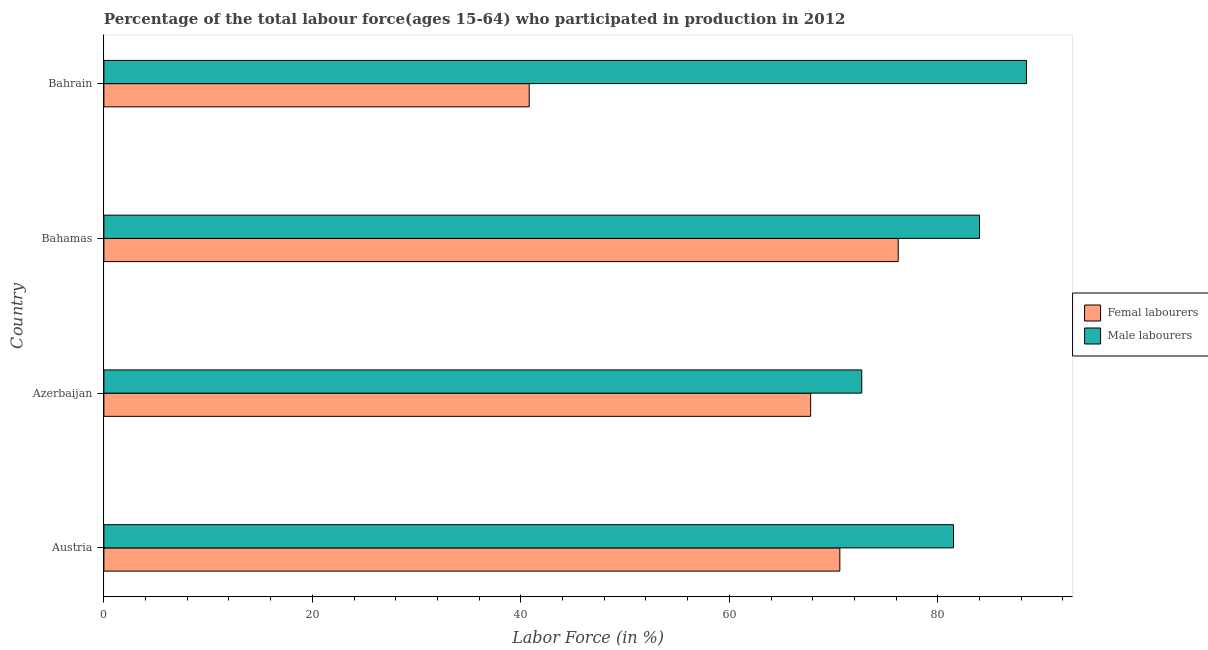How many different coloured bars are there?
Make the answer very short. 2. How many bars are there on the 1st tick from the bottom?
Your answer should be very brief. 2. What is the label of the 2nd group of bars from the top?
Make the answer very short. Bahamas. What is the percentage of male labour force in Bahamas?
Provide a succinct answer. 84. Across all countries, what is the maximum percentage of male labour force?
Provide a succinct answer. 88.5. Across all countries, what is the minimum percentage of female labor force?
Keep it short and to the point. 40.8. In which country was the percentage of male labour force maximum?
Make the answer very short. Bahrain. In which country was the percentage of male labour force minimum?
Provide a short and direct response. Azerbaijan. What is the total percentage of female labor force in the graph?
Offer a terse response. 255.4. What is the difference between the percentage of female labor force in Austria and that in Bahrain?
Offer a very short reply. 29.8. What is the difference between the percentage of male labour force in Azerbaijan and the percentage of female labor force in Bahamas?
Your answer should be very brief. -3.5. What is the average percentage of male labour force per country?
Offer a very short reply. 81.67. What is the ratio of the percentage of female labor force in Austria to that in Bahrain?
Offer a very short reply. 1.73. Is the difference between the percentage of female labor force in Austria and Azerbaijan greater than the difference between the percentage of male labour force in Austria and Azerbaijan?
Offer a very short reply. No. What is the difference between the highest and the lowest percentage of male labour force?
Your answer should be very brief. 15.8. In how many countries, is the percentage of female labor force greater than the average percentage of female labor force taken over all countries?
Your response must be concise. 3. What does the 1st bar from the top in Azerbaijan represents?
Give a very brief answer. Male labourers. What does the 1st bar from the bottom in Bahamas represents?
Your response must be concise. Femal labourers. How many bars are there?
Give a very brief answer. 8. Are the values on the major ticks of X-axis written in scientific E-notation?
Provide a short and direct response. No. Does the graph contain any zero values?
Provide a short and direct response. No. Does the graph contain grids?
Your response must be concise. No. Where does the legend appear in the graph?
Your answer should be very brief. Center right. How many legend labels are there?
Give a very brief answer. 2. What is the title of the graph?
Offer a terse response. Percentage of the total labour force(ages 15-64) who participated in production in 2012. What is the label or title of the X-axis?
Keep it short and to the point. Labor Force (in %). What is the Labor Force (in %) of Femal labourers in Austria?
Provide a succinct answer. 70.6. What is the Labor Force (in %) in Male labourers in Austria?
Provide a short and direct response. 81.5. What is the Labor Force (in %) of Femal labourers in Azerbaijan?
Your answer should be compact. 67.8. What is the Labor Force (in %) in Male labourers in Azerbaijan?
Ensure brevity in your answer.  72.7. What is the Labor Force (in %) in Femal labourers in Bahamas?
Give a very brief answer. 76.2. What is the Labor Force (in %) in Male labourers in Bahamas?
Make the answer very short. 84. What is the Labor Force (in %) of Femal labourers in Bahrain?
Provide a short and direct response. 40.8. What is the Labor Force (in %) in Male labourers in Bahrain?
Your answer should be compact. 88.5. Across all countries, what is the maximum Labor Force (in %) of Femal labourers?
Provide a short and direct response. 76.2. Across all countries, what is the maximum Labor Force (in %) in Male labourers?
Ensure brevity in your answer.  88.5. Across all countries, what is the minimum Labor Force (in %) in Femal labourers?
Keep it short and to the point. 40.8. Across all countries, what is the minimum Labor Force (in %) in Male labourers?
Keep it short and to the point. 72.7. What is the total Labor Force (in %) in Femal labourers in the graph?
Keep it short and to the point. 255.4. What is the total Labor Force (in %) in Male labourers in the graph?
Your answer should be very brief. 326.7. What is the difference between the Labor Force (in %) in Femal labourers in Austria and that in Bahamas?
Your answer should be compact. -5.6. What is the difference between the Labor Force (in %) in Femal labourers in Austria and that in Bahrain?
Provide a short and direct response. 29.8. What is the difference between the Labor Force (in %) of Male labourers in Austria and that in Bahrain?
Provide a short and direct response. -7. What is the difference between the Labor Force (in %) of Femal labourers in Azerbaijan and that in Bahamas?
Your response must be concise. -8.4. What is the difference between the Labor Force (in %) in Male labourers in Azerbaijan and that in Bahamas?
Provide a short and direct response. -11.3. What is the difference between the Labor Force (in %) of Femal labourers in Azerbaijan and that in Bahrain?
Offer a very short reply. 27. What is the difference between the Labor Force (in %) in Male labourers in Azerbaijan and that in Bahrain?
Your response must be concise. -15.8. What is the difference between the Labor Force (in %) in Femal labourers in Bahamas and that in Bahrain?
Keep it short and to the point. 35.4. What is the difference between the Labor Force (in %) of Femal labourers in Austria and the Labor Force (in %) of Male labourers in Azerbaijan?
Keep it short and to the point. -2.1. What is the difference between the Labor Force (in %) of Femal labourers in Austria and the Labor Force (in %) of Male labourers in Bahrain?
Your answer should be compact. -17.9. What is the difference between the Labor Force (in %) in Femal labourers in Azerbaijan and the Labor Force (in %) in Male labourers in Bahamas?
Keep it short and to the point. -16.2. What is the difference between the Labor Force (in %) of Femal labourers in Azerbaijan and the Labor Force (in %) of Male labourers in Bahrain?
Provide a short and direct response. -20.7. What is the difference between the Labor Force (in %) in Femal labourers in Bahamas and the Labor Force (in %) in Male labourers in Bahrain?
Your response must be concise. -12.3. What is the average Labor Force (in %) in Femal labourers per country?
Offer a very short reply. 63.85. What is the average Labor Force (in %) in Male labourers per country?
Offer a terse response. 81.67. What is the difference between the Labor Force (in %) of Femal labourers and Labor Force (in %) of Male labourers in Austria?
Provide a succinct answer. -10.9. What is the difference between the Labor Force (in %) of Femal labourers and Labor Force (in %) of Male labourers in Bahrain?
Your response must be concise. -47.7. What is the ratio of the Labor Force (in %) in Femal labourers in Austria to that in Azerbaijan?
Give a very brief answer. 1.04. What is the ratio of the Labor Force (in %) of Male labourers in Austria to that in Azerbaijan?
Your answer should be very brief. 1.12. What is the ratio of the Labor Force (in %) in Femal labourers in Austria to that in Bahamas?
Make the answer very short. 0.93. What is the ratio of the Labor Force (in %) of Male labourers in Austria to that in Bahamas?
Ensure brevity in your answer.  0.97. What is the ratio of the Labor Force (in %) in Femal labourers in Austria to that in Bahrain?
Keep it short and to the point. 1.73. What is the ratio of the Labor Force (in %) of Male labourers in Austria to that in Bahrain?
Give a very brief answer. 0.92. What is the ratio of the Labor Force (in %) in Femal labourers in Azerbaijan to that in Bahamas?
Offer a terse response. 0.89. What is the ratio of the Labor Force (in %) of Male labourers in Azerbaijan to that in Bahamas?
Provide a short and direct response. 0.87. What is the ratio of the Labor Force (in %) of Femal labourers in Azerbaijan to that in Bahrain?
Give a very brief answer. 1.66. What is the ratio of the Labor Force (in %) of Male labourers in Azerbaijan to that in Bahrain?
Keep it short and to the point. 0.82. What is the ratio of the Labor Force (in %) of Femal labourers in Bahamas to that in Bahrain?
Provide a short and direct response. 1.87. What is the ratio of the Labor Force (in %) of Male labourers in Bahamas to that in Bahrain?
Your response must be concise. 0.95. What is the difference between the highest and the second highest Labor Force (in %) in Femal labourers?
Ensure brevity in your answer.  5.6. What is the difference between the highest and the lowest Labor Force (in %) of Femal labourers?
Offer a very short reply. 35.4. What is the difference between the highest and the lowest Labor Force (in %) of Male labourers?
Keep it short and to the point. 15.8. 